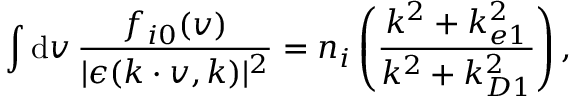Convert formula to latex. <formula><loc_0><loc_0><loc_500><loc_500>\int d v \, \frac { f _ { i 0 } ( v ) } { | \epsilon ( k \cdot v , k ) | ^ { 2 } } = n _ { i } \left ( \frac { k ^ { 2 } + k _ { e 1 } ^ { 2 } } { k ^ { 2 } + k _ { D 1 } ^ { 2 } } \right ) ,</formula> 